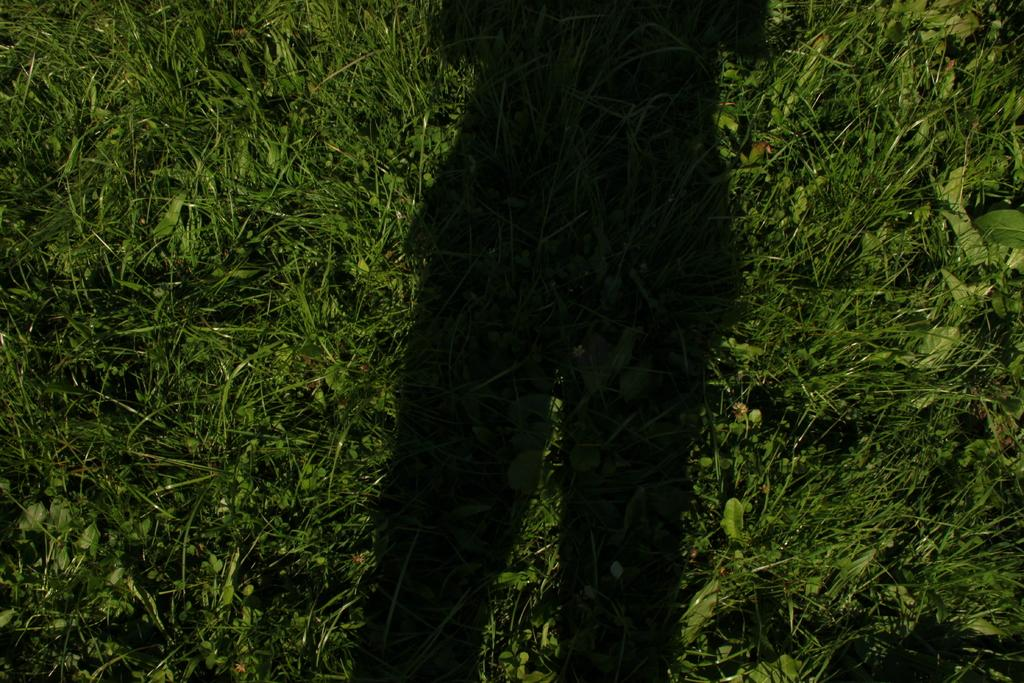What can be seen in the image that is not a solid object? There is a shadow in the image. What type of vegetation is visible in the image? There is grass visible in the image. What type of quartz can be seen in the image? There is no quartz present in the image. What type of clouds can be seen in the image? There are no clouds visible in the image; it only shows a shadow and grass. 